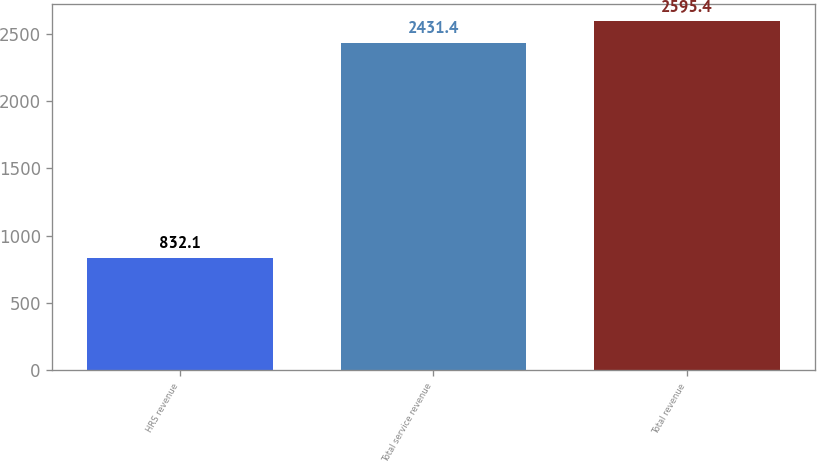Convert chart. <chart><loc_0><loc_0><loc_500><loc_500><bar_chart><fcel>HRS revenue<fcel>Total service revenue<fcel>Total revenue<nl><fcel>832.1<fcel>2431.4<fcel>2595.4<nl></chart> 